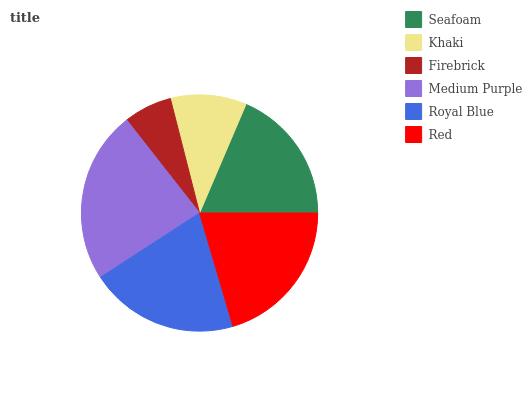Is Firebrick the minimum?
Answer yes or no. Yes. Is Medium Purple the maximum?
Answer yes or no. Yes. Is Khaki the minimum?
Answer yes or no. No. Is Khaki the maximum?
Answer yes or no. No. Is Seafoam greater than Khaki?
Answer yes or no. Yes. Is Khaki less than Seafoam?
Answer yes or no. Yes. Is Khaki greater than Seafoam?
Answer yes or no. No. Is Seafoam less than Khaki?
Answer yes or no. No. Is Royal Blue the high median?
Answer yes or no. Yes. Is Seafoam the low median?
Answer yes or no. Yes. Is Medium Purple the high median?
Answer yes or no. No. Is Royal Blue the low median?
Answer yes or no. No. 